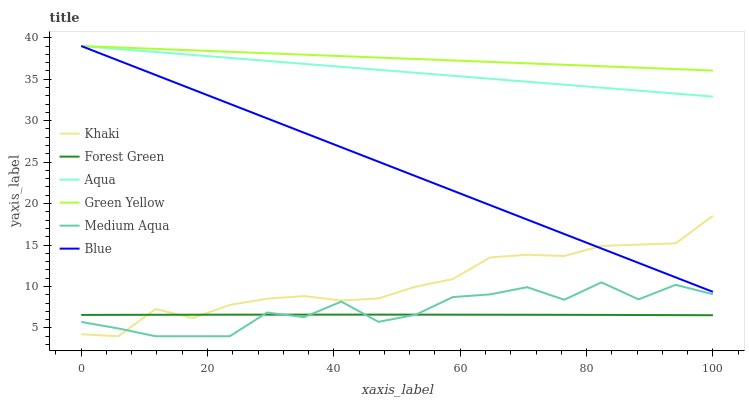Does Forest Green have the minimum area under the curve?
Answer yes or no. Yes. Does Green Yellow have the maximum area under the curve?
Answer yes or no. Yes. Does Khaki have the minimum area under the curve?
Answer yes or no. No. Does Khaki have the maximum area under the curve?
Answer yes or no. No. Is Green Yellow the smoothest?
Answer yes or no. Yes. Is Medium Aqua the roughest?
Answer yes or no. Yes. Is Khaki the smoothest?
Answer yes or no. No. Is Khaki the roughest?
Answer yes or no. No. Does Khaki have the lowest value?
Answer yes or no. Yes. Does Aqua have the lowest value?
Answer yes or no. No. Does Green Yellow have the highest value?
Answer yes or no. Yes. Does Khaki have the highest value?
Answer yes or no. No. Is Forest Green less than Blue?
Answer yes or no. Yes. Is Blue greater than Medium Aqua?
Answer yes or no. Yes. Does Aqua intersect Green Yellow?
Answer yes or no. Yes. Is Aqua less than Green Yellow?
Answer yes or no. No. Is Aqua greater than Green Yellow?
Answer yes or no. No. Does Forest Green intersect Blue?
Answer yes or no. No. 